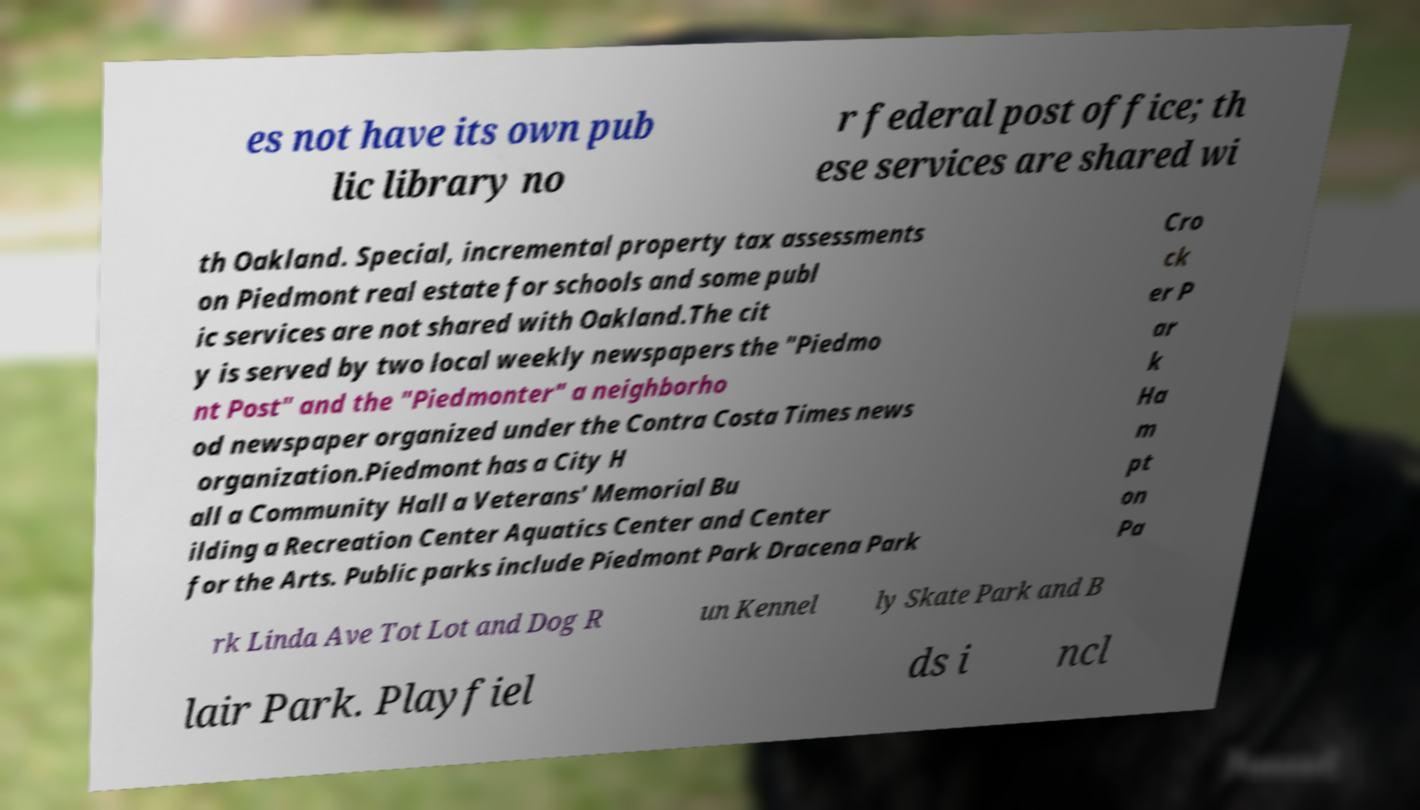Could you assist in decoding the text presented in this image and type it out clearly? es not have its own pub lic library no r federal post office; th ese services are shared wi th Oakland. Special, incremental property tax assessments on Piedmont real estate for schools and some publ ic services are not shared with Oakland.The cit y is served by two local weekly newspapers the "Piedmo nt Post" and the "Piedmonter" a neighborho od newspaper organized under the Contra Costa Times news organization.Piedmont has a City H all a Community Hall a Veterans' Memorial Bu ilding a Recreation Center Aquatics Center and Center for the Arts. Public parks include Piedmont Park Dracena Park Cro ck er P ar k Ha m pt on Pa rk Linda Ave Tot Lot and Dog R un Kennel ly Skate Park and B lair Park. Playfiel ds i ncl 